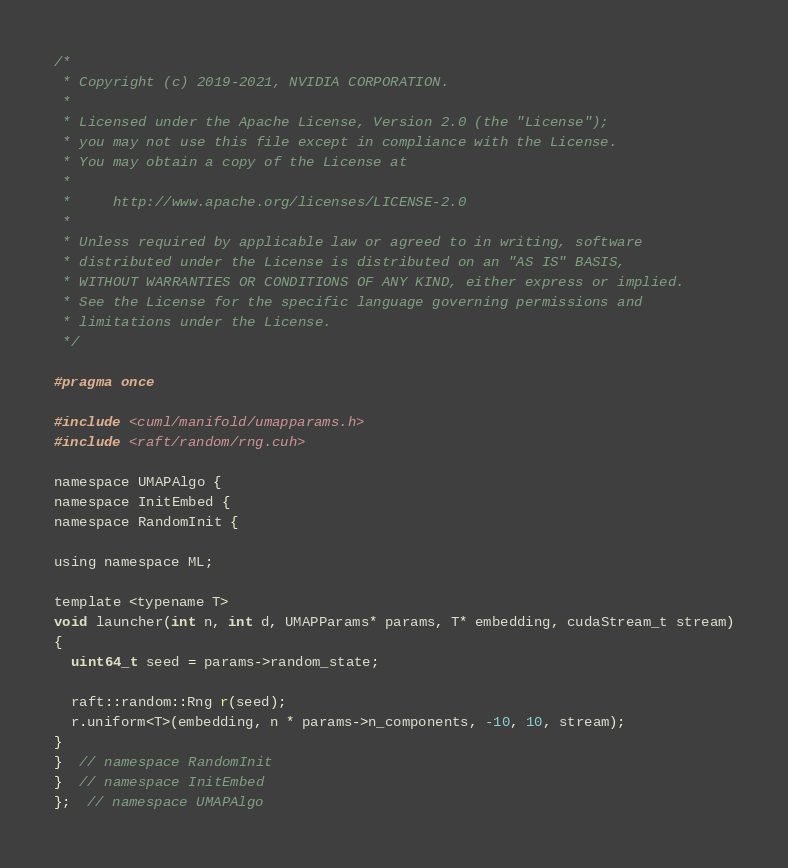Convert code to text. <code><loc_0><loc_0><loc_500><loc_500><_Cuda_>/*
 * Copyright (c) 2019-2021, NVIDIA CORPORATION.
 *
 * Licensed under the Apache License, Version 2.0 (the "License");
 * you may not use this file except in compliance with the License.
 * You may obtain a copy of the License at
 *
 *     http://www.apache.org/licenses/LICENSE-2.0
 *
 * Unless required by applicable law or agreed to in writing, software
 * distributed under the License is distributed on an "AS IS" BASIS,
 * WITHOUT WARRANTIES OR CONDITIONS OF ANY KIND, either express or implied.
 * See the License for the specific language governing permissions and
 * limitations under the License.
 */

#pragma once

#include <cuml/manifold/umapparams.h>
#include <raft/random/rng.cuh>

namespace UMAPAlgo {
namespace InitEmbed {
namespace RandomInit {

using namespace ML;

template <typename T>
void launcher(int n, int d, UMAPParams* params, T* embedding, cudaStream_t stream)
{
  uint64_t seed = params->random_state;

  raft::random::Rng r(seed);
  r.uniform<T>(embedding, n * params->n_components, -10, 10, stream);
}
}  // namespace RandomInit
}  // namespace InitEmbed
};  // namespace UMAPAlgo
</code> 